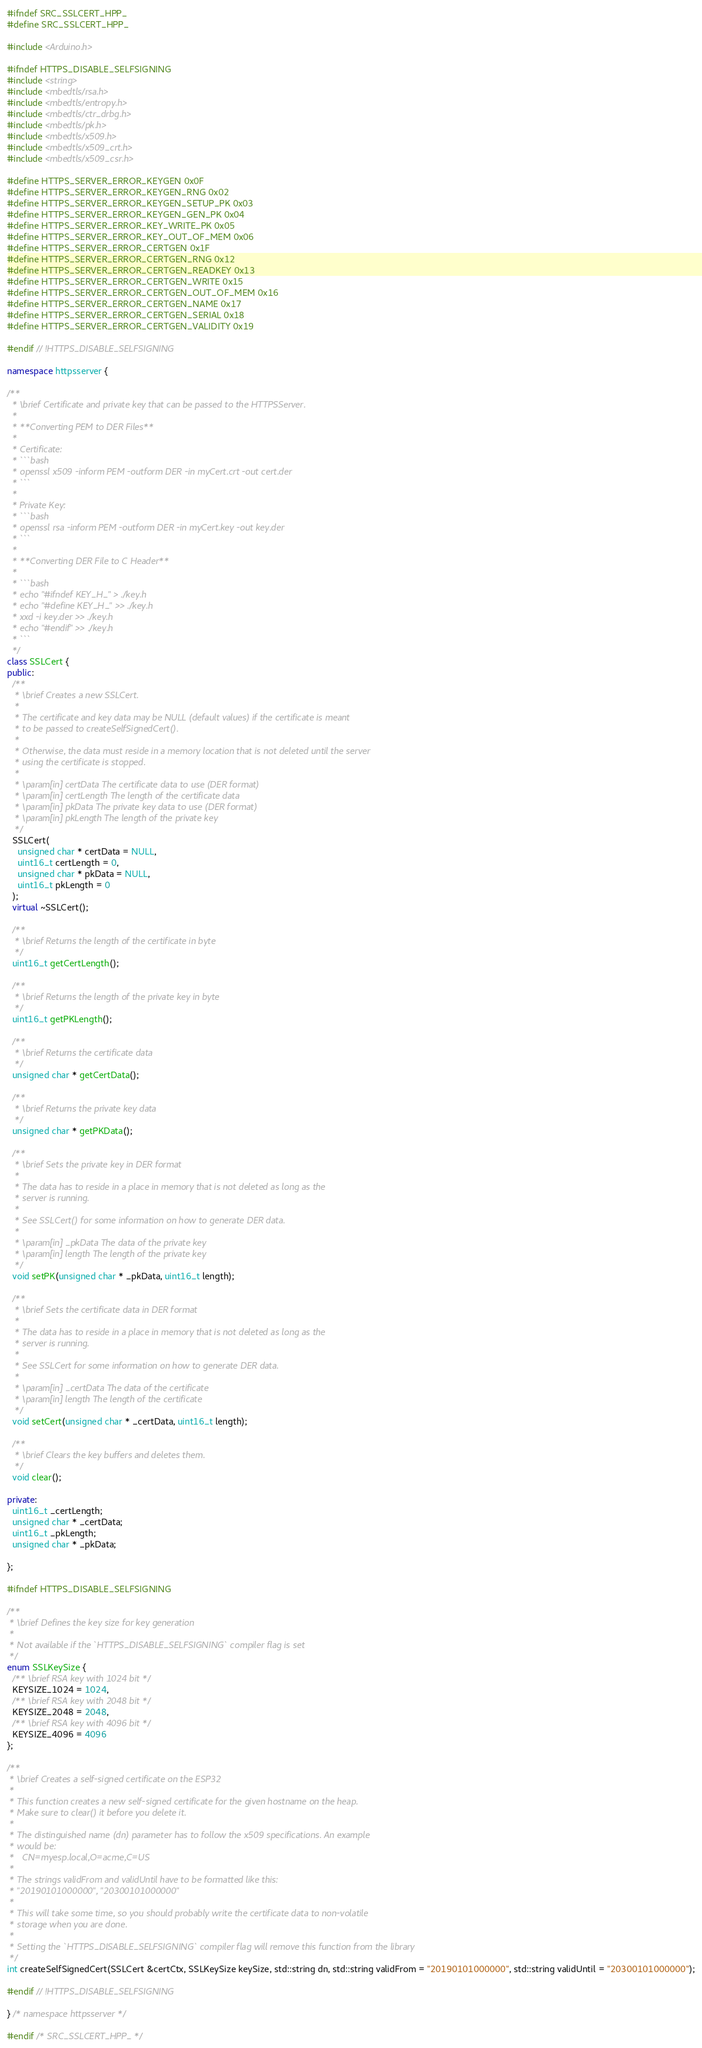<code> <loc_0><loc_0><loc_500><loc_500><_C++_>#ifndef SRC_SSLCERT_HPP_
#define SRC_SSLCERT_HPP_

#include <Arduino.h>

#ifndef HTTPS_DISABLE_SELFSIGNING
#include <string>
#include <mbedtls/rsa.h>
#include <mbedtls/entropy.h>
#include <mbedtls/ctr_drbg.h>
#include <mbedtls/pk.h>
#include <mbedtls/x509.h>
#include <mbedtls/x509_crt.h>
#include <mbedtls/x509_csr.h>

#define HTTPS_SERVER_ERROR_KEYGEN 0x0F
#define HTTPS_SERVER_ERROR_KEYGEN_RNG 0x02
#define HTTPS_SERVER_ERROR_KEYGEN_SETUP_PK 0x03
#define HTTPS_SERVER_ERROR_KEYGEN_GEN_PK 0x04
#define HTTPS_SERVER_ERROR_KEY_WRITE_PK 0x05
#define HTTPS_SERVER_ERROR_KEY_OUT_OF_MEM 0x06
#define HTTPS_SERVER_ERROR_CERTGEN 0x1F
#define HTTPS_SERVER_ERROR_CERTGEN_RNG 0x12
#define HTTPS_SERVER_ERROR_CERTGEN_READKEY 0x13
#define HTTPS_SERVER_ERROR_CERTGEN_WRITE 0x15
#define HTTPS_SERVER_ERROR_CERTGEN_OUT_OF_MEM 0x16
#define HTTPS_SERVER_ERROR_CERTGEN_NAME 0x17
#define HTTPS_SERVER_ERROR_CERTGEN_SERIAL 0x18
#define HTTPS_SERVER_ERROR_CERTGEN_VALIDITY 0x19

#endif // !HTTPS_DISABLE_SELFSIGNING

namespace httpsserver {

/**
  * \brief Certificate and private key that can be passed to the HTTPSServer.
  * 
  * **Converting PEM to DER Files**
  * 
  * Certificate:
  * ```bash
  * openssl x509 -inform PEM -outform DER -in myCert.crt -out cert.der
  * ```
  * 
  * Private Key:
  * ```bash
  * openssl rsa -inform PEM -outform DER -in myCert.key -out key.der
  * ```
  * 
  * **Converting DER File to C Header**
  * 
  * ```bash
  * echo "#ifndef KEY_H_" > ./key.h
  * echo "#define KEY_H_" >> ./key.h
  * xxd -i key.der >> ./key.h
  * echo "#endif" >> ./key.h
  * ```
  */
class SSLCert {
public:
  /**
   * \brief Creates a new SSLCert.
   * 
   * The certificate and key data may be NULL (default values) if the certificate is meant
   * to be passed to createSelfSignedCert().
   * 
   * Otherwise, the data must reside in a memory location that is not deleted until the server
   * using the certificate is stopped.
   * 
   * \param[in] certData The certificate data to use (DER format)
   * \param[in] certLength The length of the certificate data
   * \param[in] pkData The private key data to use (DER format)
   * \param[in] pkLength The length of the private key
   */
  SSLCert(
    unsigned char * certData = NULL,
    uint16_t certLength = 0,
    unsigned char * pkData = NULL,
    uint16_t pkLength = 0
  );
  virtual ~SSLCert();

  /**
   * \brief Returns the length of the certificate in byte
   */
  uint16_t getCertLength();

  /**
   * \brief Returns the length of the private key in byte
   */
  uint16_t getPKLength();

  /**
   * \brief Returns the certificate data
   */
  unsigned char * getCertData();

  /**
   * \brief Returns the private key data
   */
  unsigned char * getPKData();

  /**
   * \brief Sets the private key in DER format
   * 
   * The data has to reside in a place in memory that is not deleted as long as the
   * server is running.
   * 
   * See SSLCert() for some information on how to generate DER data.
   * 
   * \param[in] _pkData The data of the private key
   * \param[in] length The length of the private key
   */
  void setPK(unsigned char * _pkData, uint16_t length);

  /**
   * \brief Sets the certificate data in DER format
   * 
   * The data has to reside in a place in memory that is not deleted as long as the
   * server is running.
   * 
   * See SSLCert for some information on how to generate DER data.
   * 
   * \param[in] _certData The data of the certificate
   * \param[in] length The length of the certificate
   */
  void setCert(unsigned char * _certData, uint16_t length);

  /**
   * \brief Clears the key buffers and deletes them.
   */
  void clear();

private:
  uint16_t _certLength;
  unsigned char * _certData;
  uint16_t _pkLength;
  unsigned char * _pkData;

};

#ifndef HTTPS_DISABLE_SELFSIGNING

/**
 * \brief Defines the key size for key generation
 * 
 * Not available if the `HTTPS_DISABLE_SELFSIGNING` compiler flag is set
 */
enum SSLKeySize {
  /** \brief RSA key with 1024 bit */
  KEYSIZE_1024 = 1024,
  /** \brief RSA key with 2048 bit */
  KEYSIZE_2048 = 2048,
  /** \brief RSA key with 4096 bit */
  KEYSIZE_4096 = 4096
};

/**
 * \brief Creates a self-signed certificate on the ESP32
 * 
 * This function creates a new self-signed certificate for the given hostname on the heap.
 * Make sure to clear() it before you delete it.
 * 
 * The distinguished name (dn) parameter has to follow the x509 specifications. An example
 * would be:
 *   CN=myesp.local,O=acme,C=US
 * 
 * The strings validFrom and validUntil have to be formatted like this:
 * "20190101000000", "20300101000000"
 * 
 * This will take some time, so you should probably write the certificate data to non-volatile
 * storage when you are done.
 * 
 * Setting the `HTTPS_DISABLE_SELFSIGNING` compiler flag will remove this function from the library
 */
int createSelfSignedCert(SSLCert &certCtx, SSLKeySize keySize, std::string dn, std::string validFrom = "20190101000000", std::string validUntil = "20300101000000");

#endif // !HTTPS_DISABLE_SELFSIGNING

} /* namespace httpsserver */

#endif /* SRC_SSLCERT_HPP_ */
</code> 